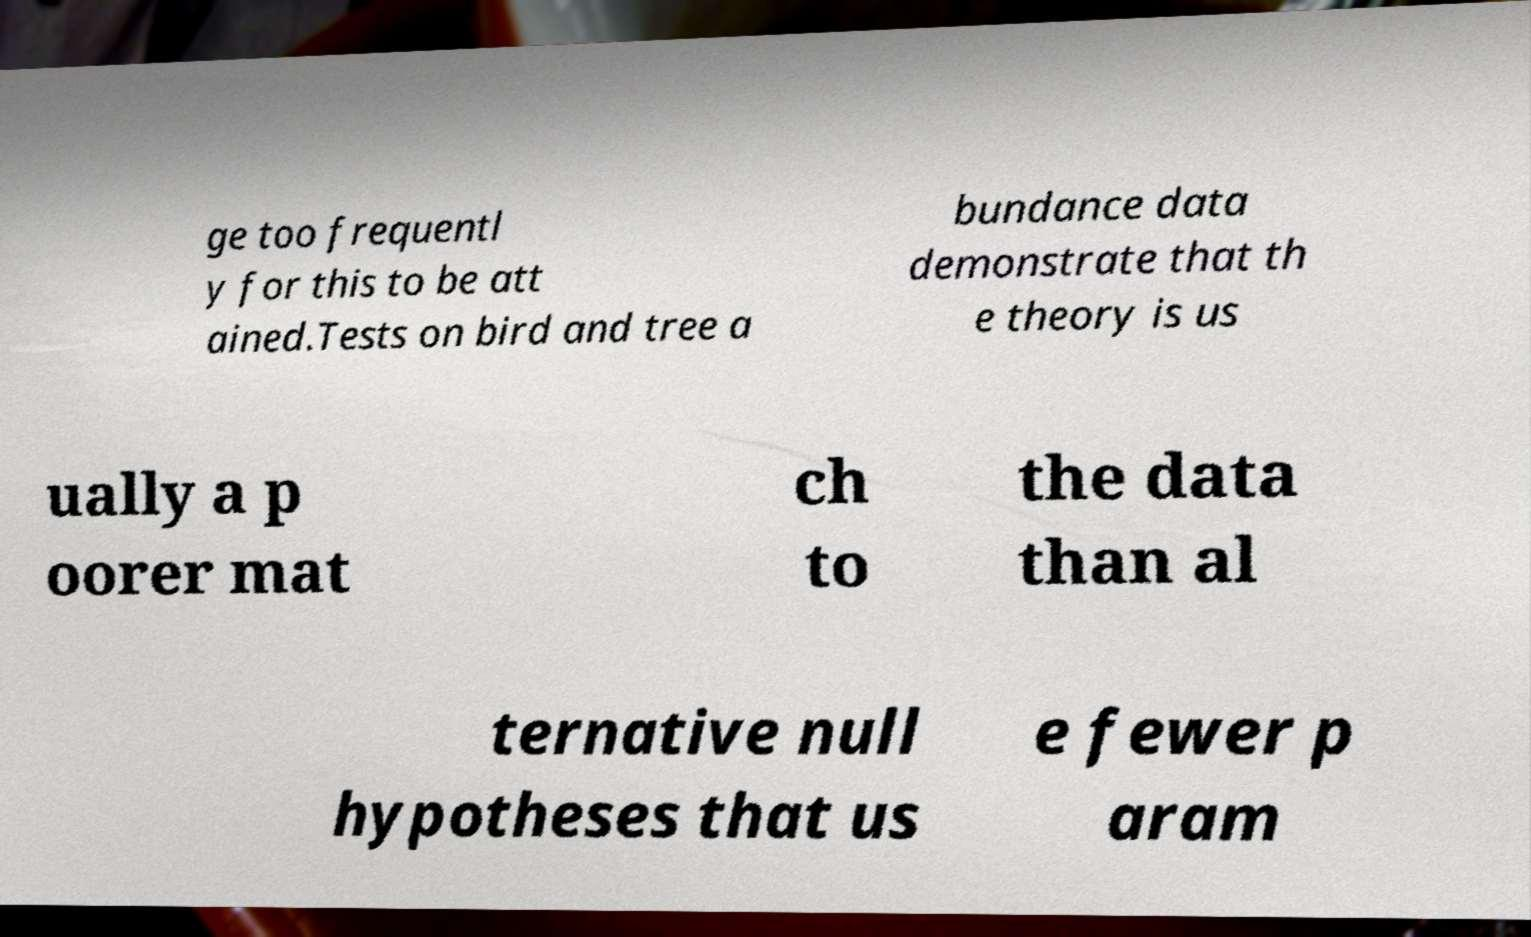There's text embedded in this image that I need extracted. Can you transcribe it verbatim? ge too frequentl y for this to be att ained.Tests on bird and tree a bundance data demonstrate that th e theory is us ually a p oorer mat ch to the data than al ternative null hypotheses that us e fewer p aram 